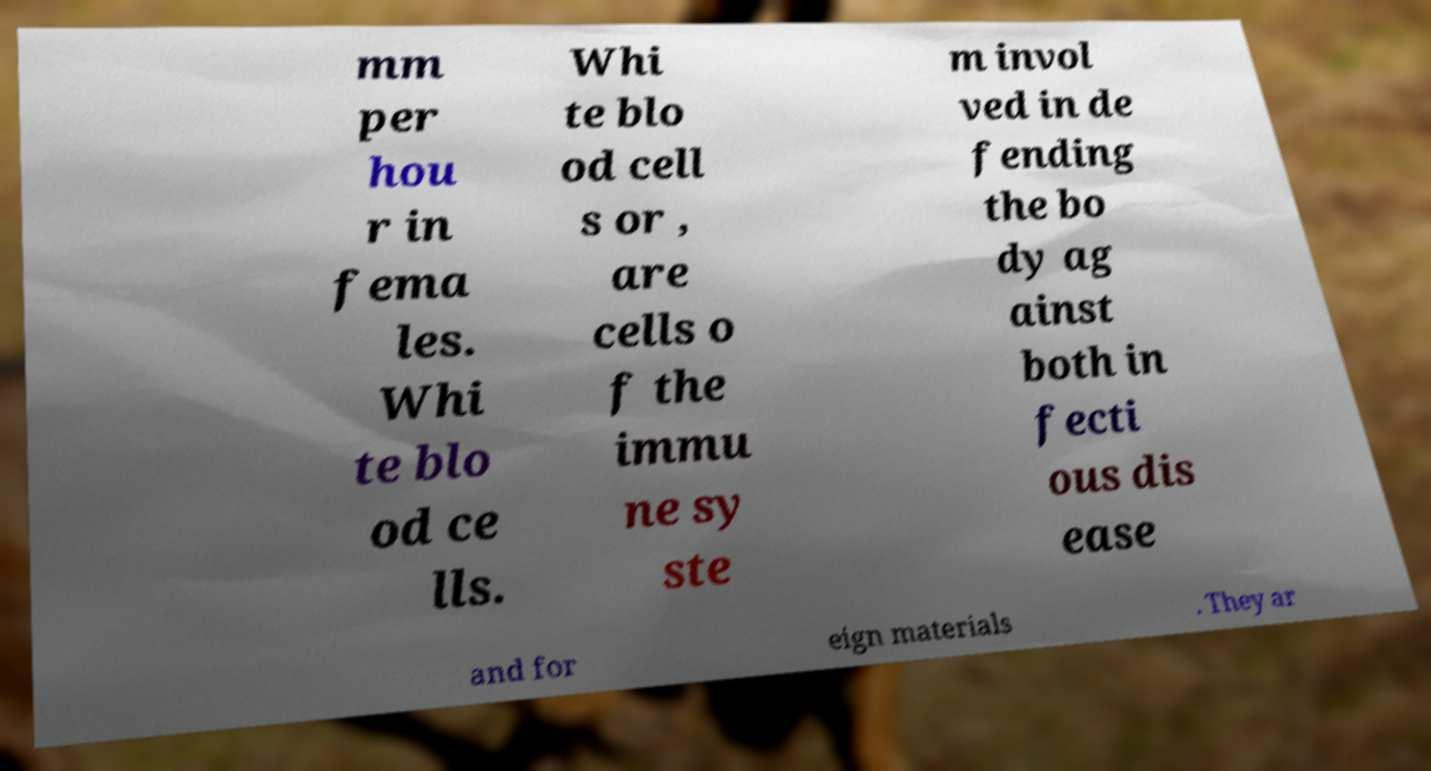What messages or text are displayed in this image? I need them in a readable, typed format. mm per hou r in fema les. Whi te blo od ce lls. Whi te blo od cell s or , are cells o f the immu ne sy ste m invol ved in de fending the bo dy ag ainst both in fecti ous dis ease and for eign materials . They ar 